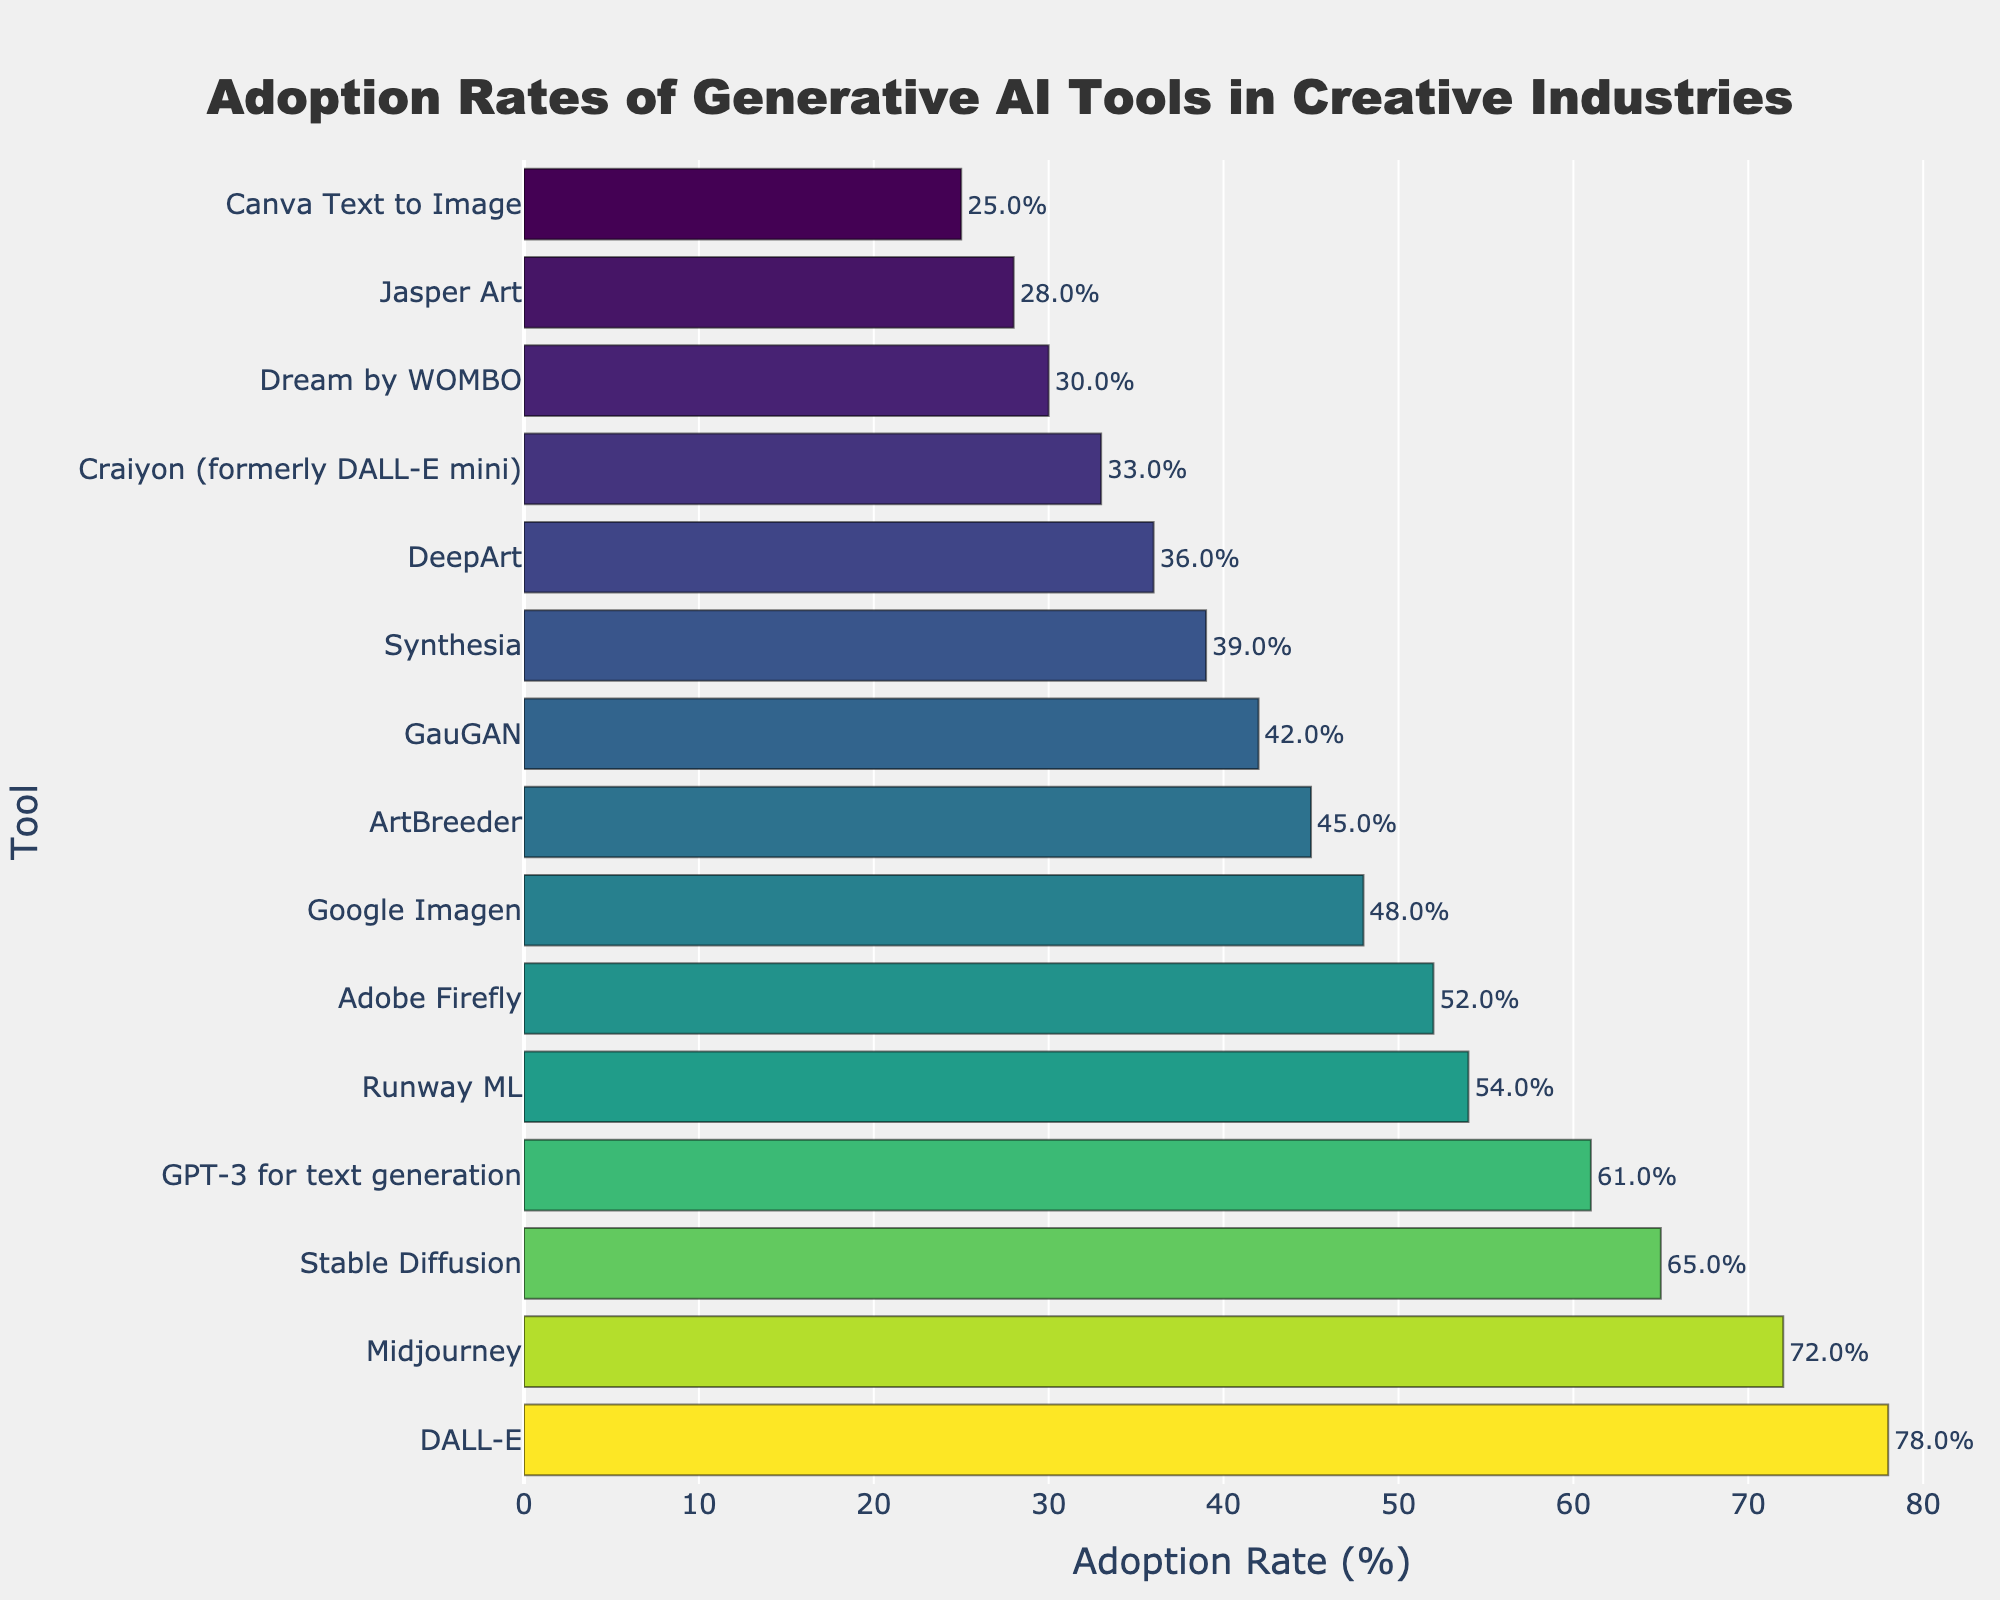What tool has the highest adoption rate? To find the tool with the highest adoption rate, look for the longest bar in the bar chart. In this case, the longest bar corresponds to DALL-E with an adoption rate of 78%.
Answer: DALL-E Which tool has a higher adoption rate, Midjourney or GPT-3 for text generation? To answer this question, compare the lengths of the bars for Midjourney and GPT-3 for text generation. Midjourney has an adoption rate of 72%, while GPT-3 for text generation has an adoption rate of 61%.
Answer: Midjourney What is the adoption rate difference between Stable Diffusion and Synthesia? Locate the bars for Stable Diffusion and Synthesia. Stable Diffusion has an adoption rate of 65%, and Synthesia has an adoption rate of 39%. Subtract 39% from 65% to find the difference.
Answer: 26% How many tools have an adoption rate greater than 50%? Count the bars that extend beyond the 50% mark. These tools are DALL-E, Midjourney, Stable Diffusion, GPT-3 for text generation, Runway ML, and Adobe Firefly. There are 6 tools in total.
Answer: 6 What is the average adoption rate of the top 3 tools? The top 3 tools are DALL-E, Midjourney, and Stable Diffusion with adoption rates of 78%, 72%, and 65%, respectively. Sum these rates (78 + 72 + 65 = 215) and divide by 3 to find the average.
Answer: 71.7% Does Canva Text to Image have an adoption rate less than 30%? Look at the bar corresponding to Canva Text to Image. The adoption rate is 25%, which is less than 30%.
Answer: Yes Which tools have the exact same color in the Viridis color scale? Identify bars with the same color shades in the chart. None of the bars share the exact same color in the Viridis colorscale; hence, no tools have the same color.
Answer: None What is the total adoption rate of the bottom 5 tools? The bottom 5 tools are DeepArt, Craiyon (formerly DALL-E mini), Dream by WOMBO, Jasper Art, and Canva Text to Image with rates of 36%, 33%, 30%, 28%, and 25%, respectively. Sum these rates (36 + 33 + 30 + 28 + 25 = 152).
Answer: 152% Which tool is immediately below Runway ML in terms of adoption rate? Identify the tool immediately below Runway ML, which has an adoption rate of 54%. This tool is Adobe Firefly, with a 52% adoption rate.
Answer: Adobe Firefly What is the difference in adoption rates between the highest and lowest adopted tools? The highest adopted tool is DALL-E with an adoption rate of 78%, and the lowest is Canva Text to Image with an adoption rate of 25%. Subtract 25% from 78% to get the difference.
Answer: 53% 